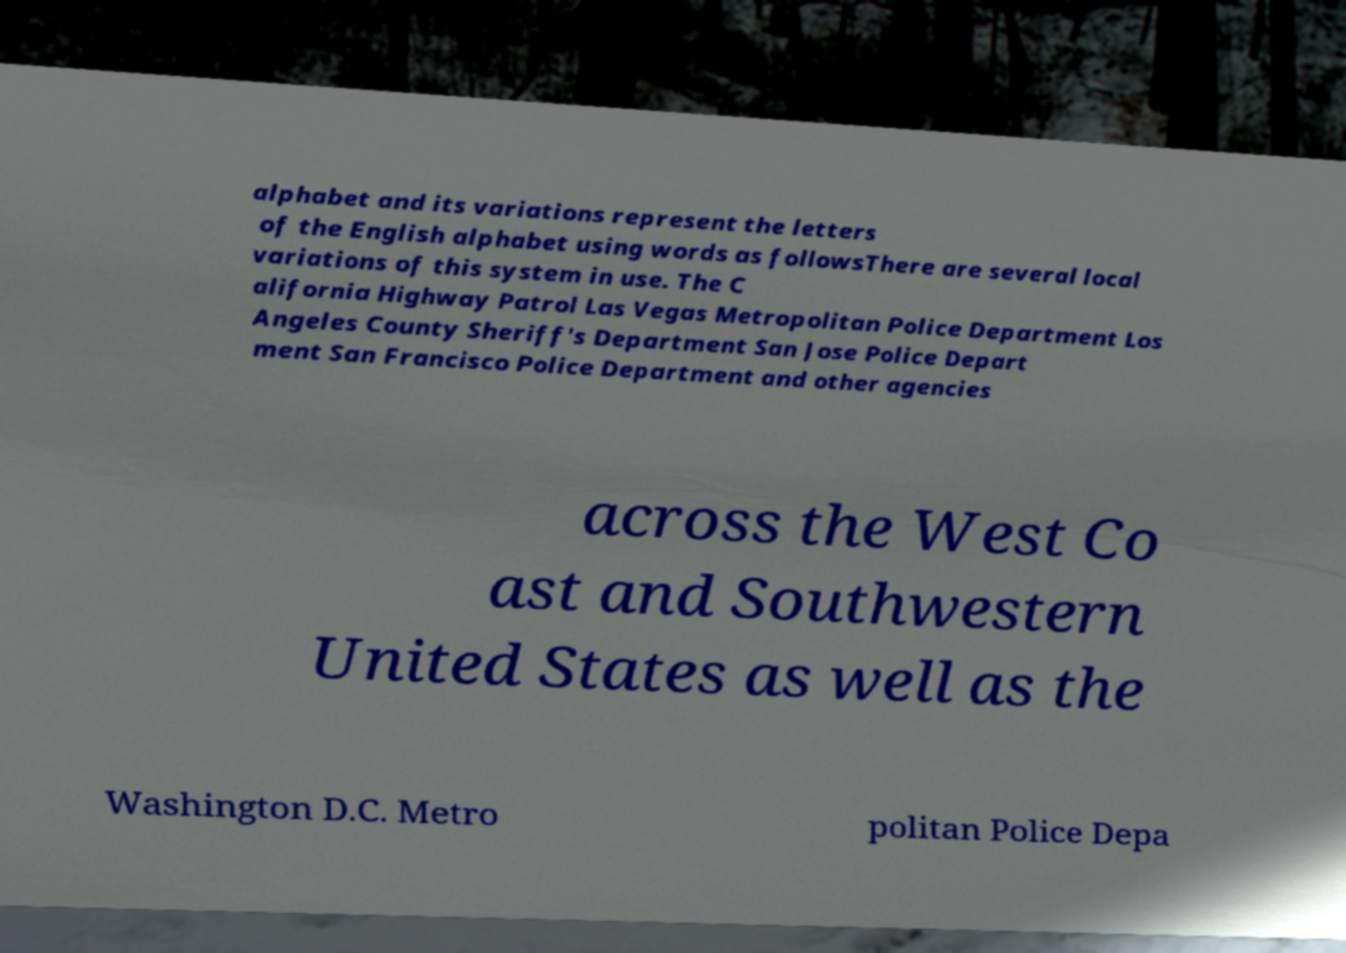Please identify and transcribe the text found in this image. alphabet and its variations represent the letters of the English alphabet using words as followsThere are several local variations of this system in use. The C alifornia Highway Patrol Las Vegas Metropolitan Police Department Los Angeles County Sheriff's Department San Jose Police Depart ment San Francisco Police Department and other agencies across the West Co ast and Southwestern United States as well as the Washington D.C. Metro politan Police Depa 